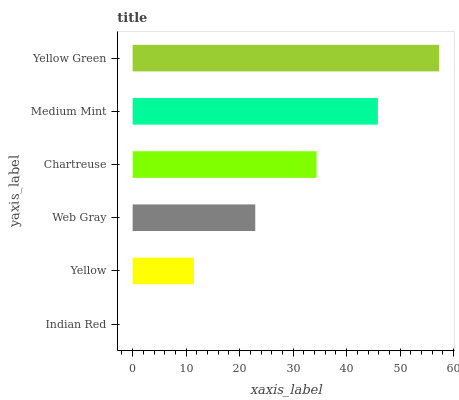Is Indian Red the minimum?
Answer yes or no. Yes. Is Yellow Green the maximum?
Answer yes or no. Yes. Is Yellow the minimum?
Answer yes or no. No. Is Yellow the maximum?
Answer yes or no. No. Is Yellow greater than Indian Red?
Answer yes or no. Yes. Is Indian Red less than Yellow?
Answer yes or no. Yes. Is Indian Red greater than Yellow?
Answer yes or no. No. Is Yellow less than Indian Red?
Answer yes or no. No. Is Chartreuse the high median?
Answer yes or no. Yes. Is Web Gray the low median?
Answer yes or no. Yes. Is Web Gray the high median?
Answer yes or no. No. Is Yellow the low median?
Answer yes or no. No. 